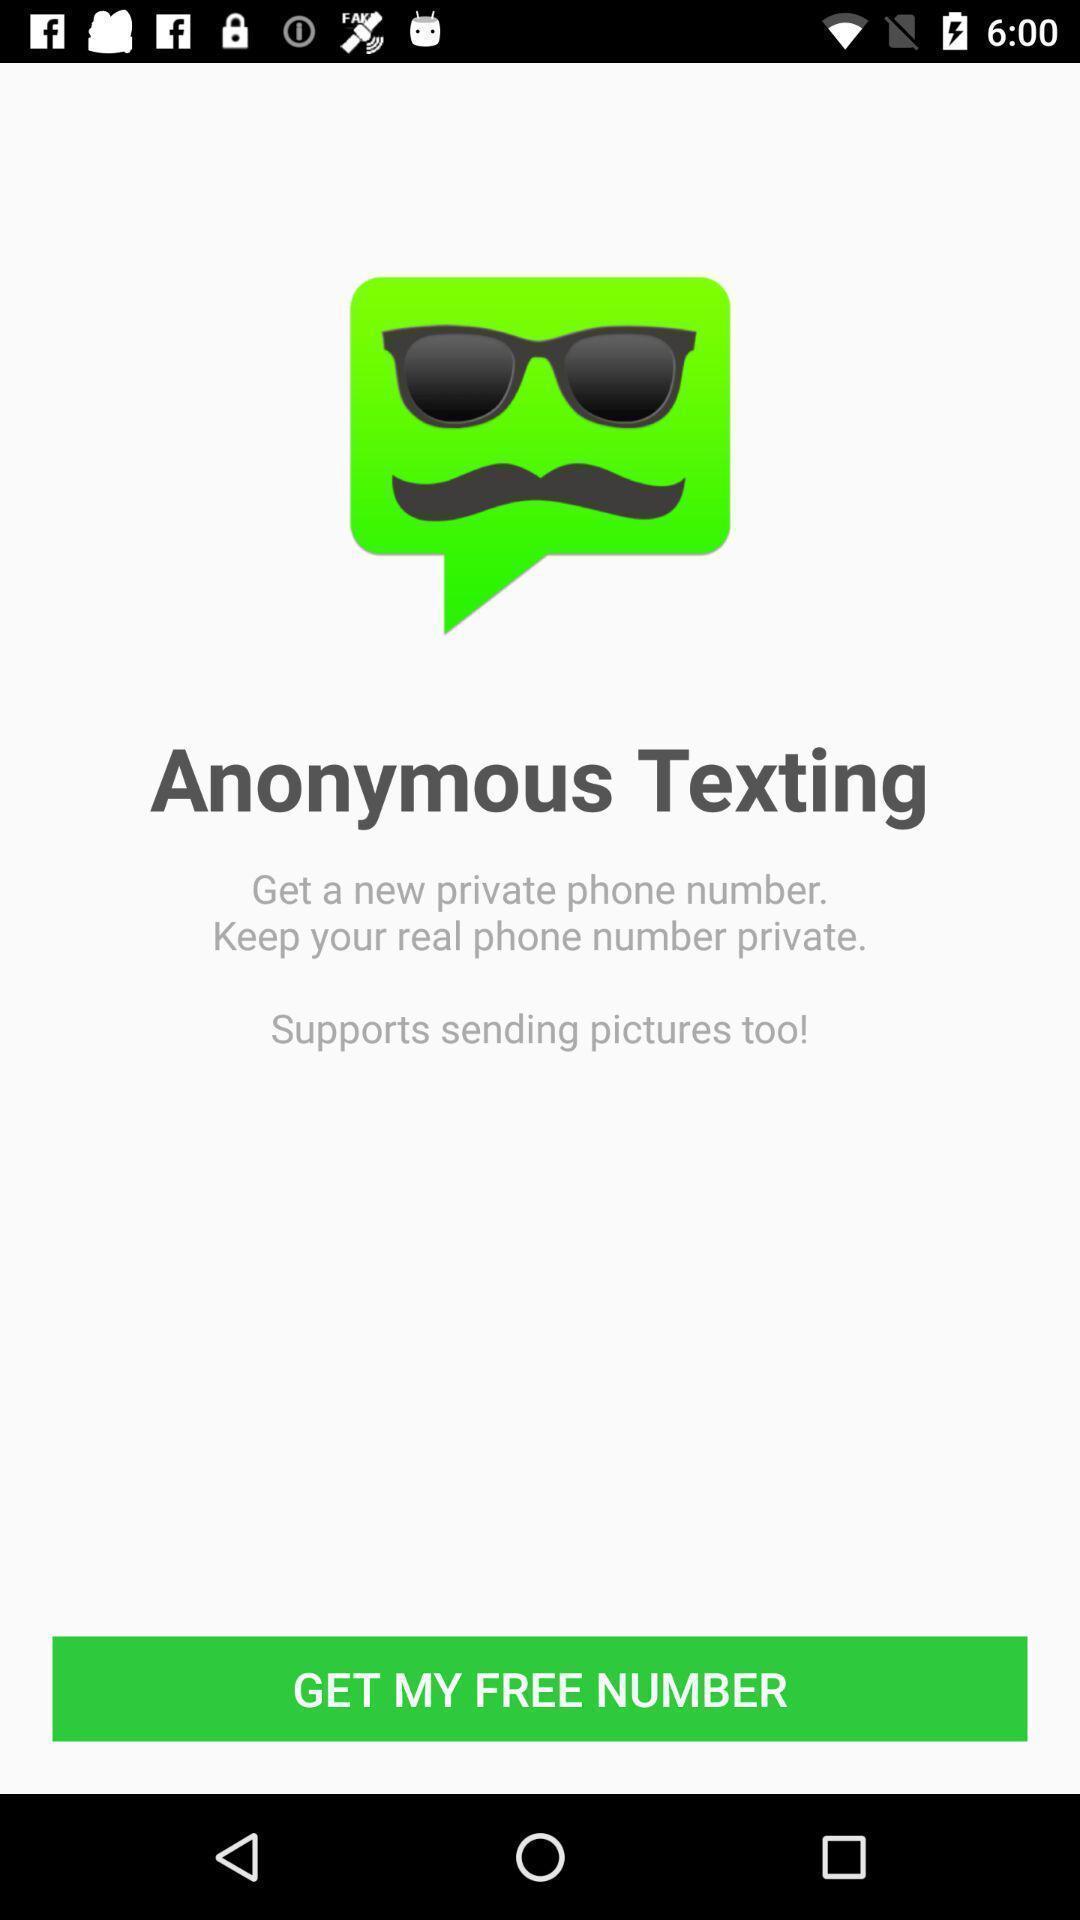Provide a textual representation of this image. Welcome page of a texting application. 